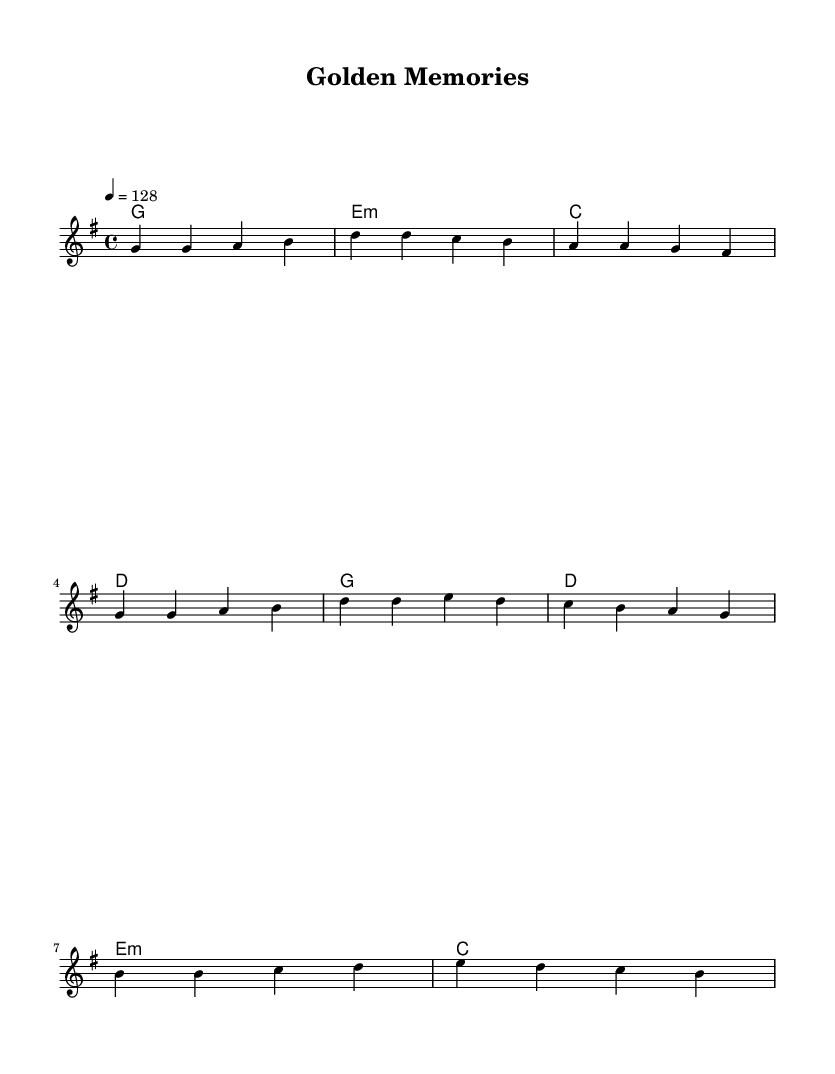What is the key signature of this music? The key signature is G major, which has one sharp (F#) indicated at the beginning of the staff.
Answer: G major What is the time signature of this piece? The time signature is 4/4, as shown by the notation at the beginning of the music, indicating that there are four beats in each measure.
Answer: 4/4 What is the tempo marking for this piece? The tempo marking indicates a speed of 128 beats per minute, as stated at the beginning with the note "4 = 128".
Answer: 128 How many measures are there in the verse section? The verse section consists of four measures, as each line in the melody represents a single measure. By counting the lines provided under the verse, we find there are four.
Answer: 4 Which chords are used in the chorus? The chords used in the chorus are G, D, E minor, and C, as indicated in the harmony section specifically tied to the chorus.
Answer: G, D, E minor, C What is the first note of the melody in the verse? The first note of the melody is G, as it appears prominently at the beginning of the verse section in the melody line.
Answer: G How many different note values are represented in the melody? The melody primarily uses quarter notes, as each note in the melody line is a quarter note, which is indicated by the duration of each note.
Answer: One (quarter notes) 